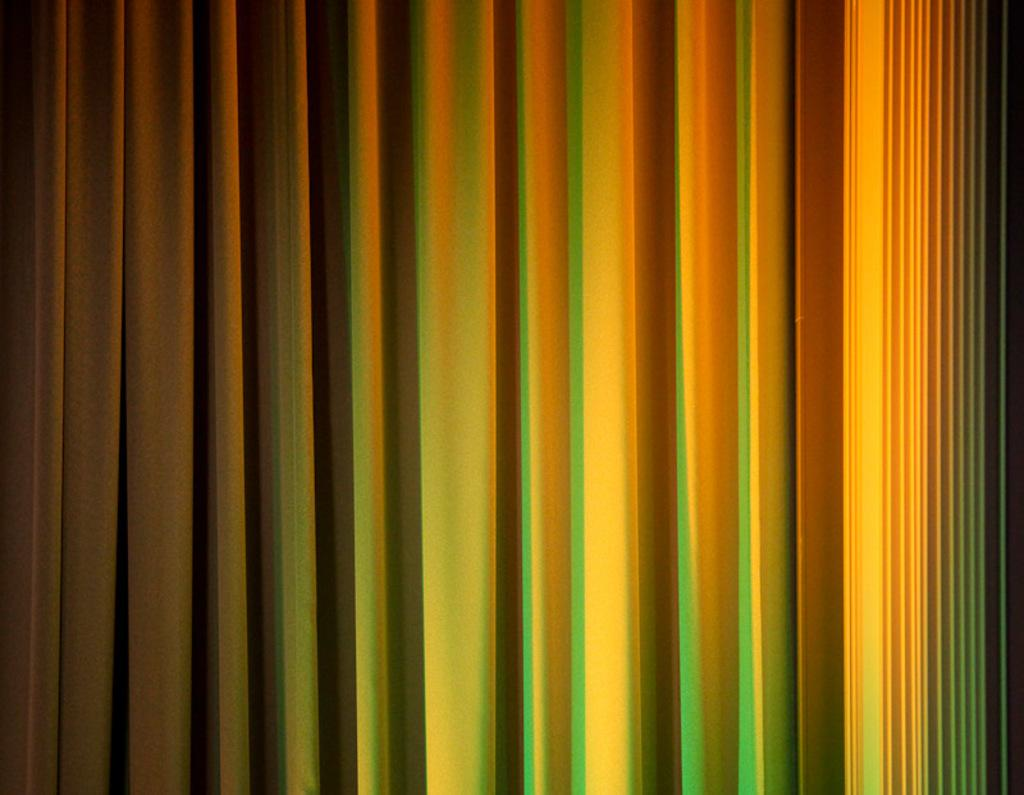What is present in the image related to window treatments? There is a curtain in the image. Can you describe the colors of the curtain? The curtain is green and yellow in color. What type of silver vegetable can be seen on the curtain in the image? There is no silver vegetable present on the curtain in the image. 